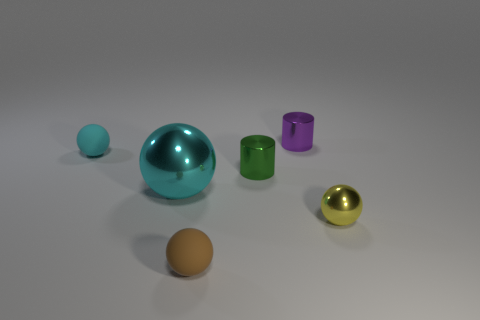Subtract all purple balls. Subtract all purple blocks. How many balls are left? 4 Add 1 tiny yellow things. How many objects exist? 7 Subtract all cylinders. How many objects are left? 4 Add 5 purple rubber things. How many purple rubber things exist? 5 Subtract 0 purple blocks. How many objects are left? 6 Subtract all tiny brown rubber objects. Subtract all big gray rubber spheres. How many objects are left? 5 Add 5 shiny objects. How many shiny objects are left? 9 